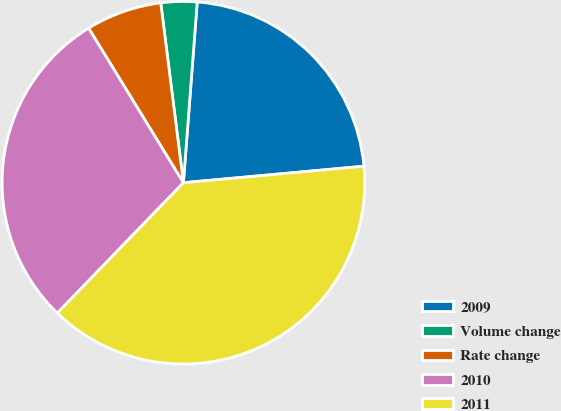Convert chart to OTSL. <chart><loc_0><loc_0><loc_500><loc_500><pie_chart><fcel>2009<fcel>Volume change<fcel>Rate change<fcel>2010<fcel>2011<nl><fcel>22.33%<fcel>3.21%<fcel>6.76%<fcel>29.01%<fcel>38.68%<nl></chart> 